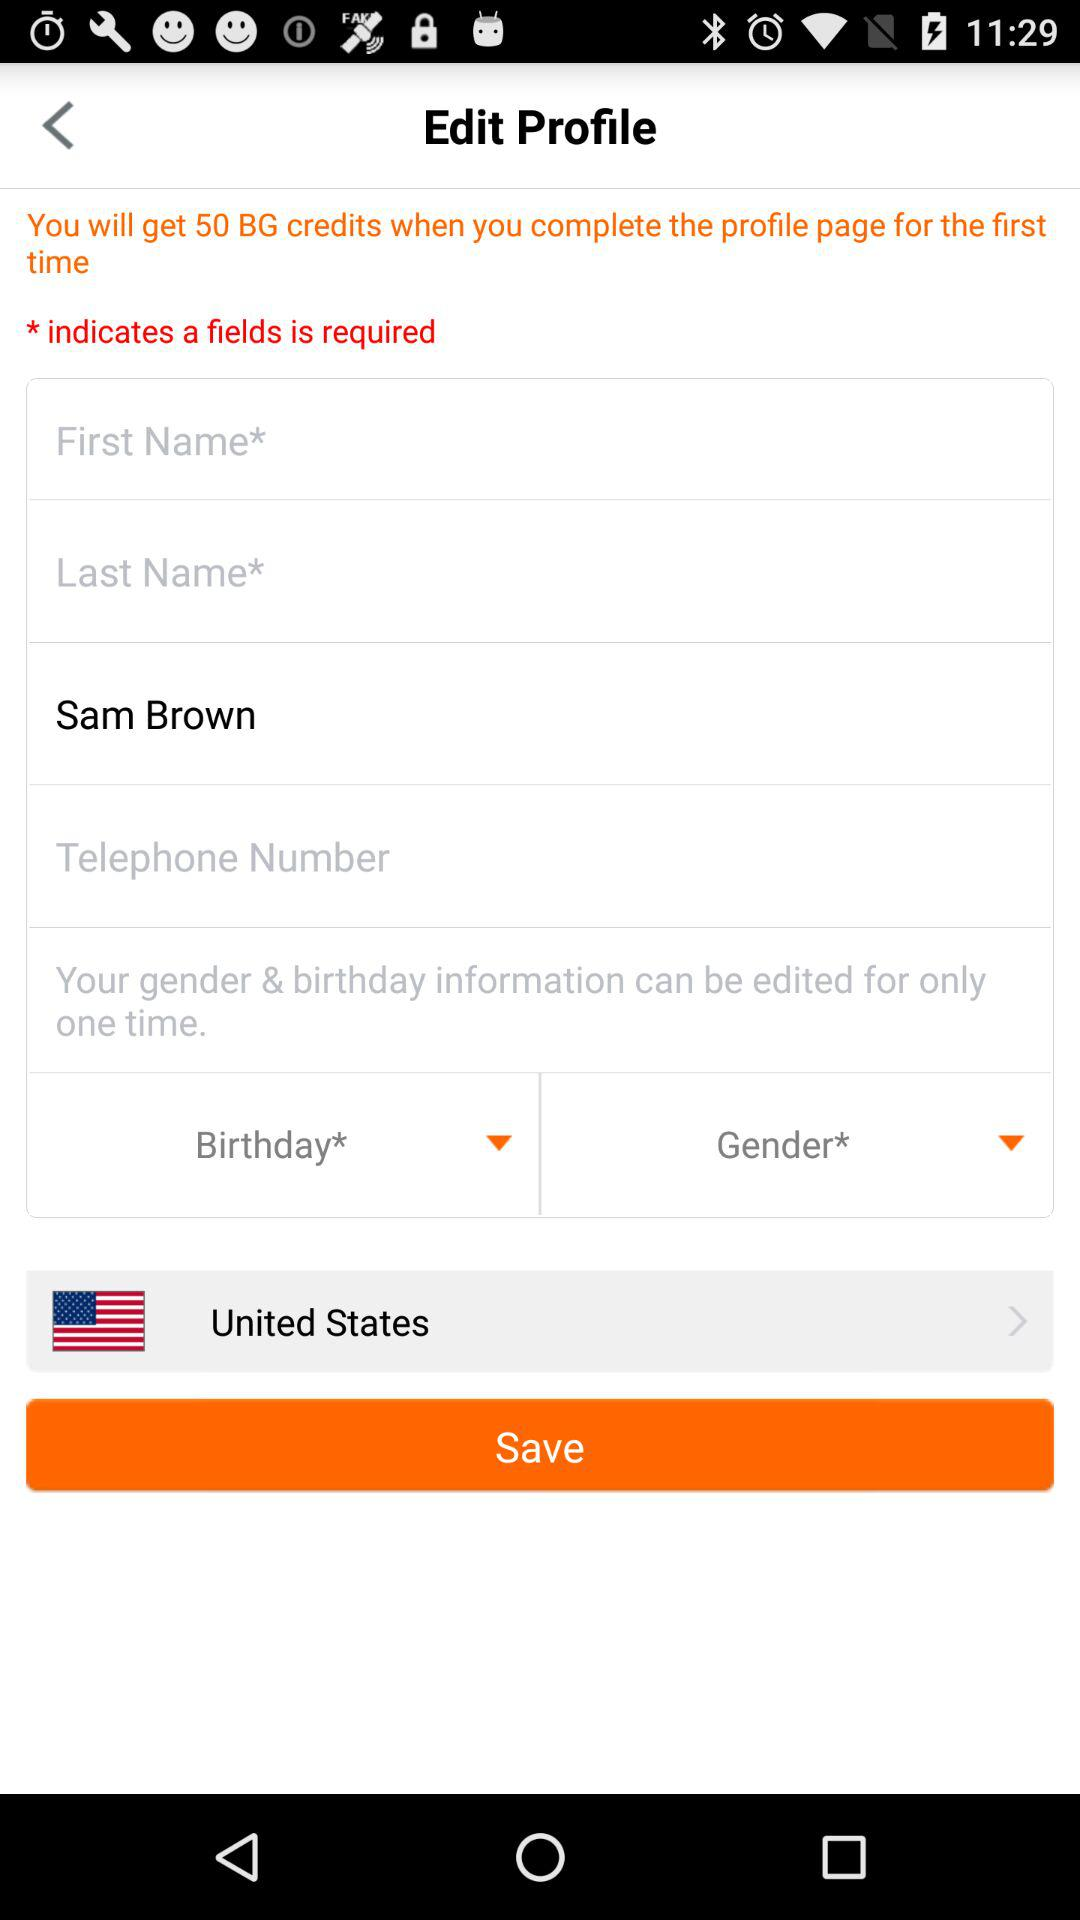How many credits do you get when completing a profile? We receive 50 BG credits. 